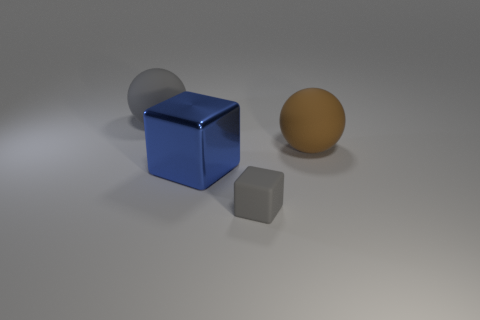Add 2 large gray objects. How many objects exist? 6 Subtract all metallic objects. Subtract all large gray spheres. How many objects are left? 2 Add 4 large matte balls. How many large matte balls are left? 6 Add 4 tiny things. How many tiny things exist? 5 Subtract 0 green cylinders. How many objects are left? 4 